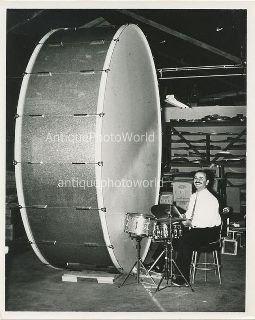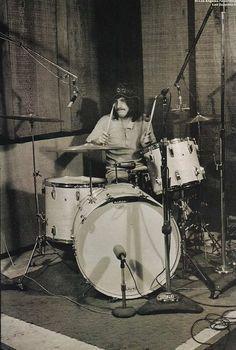The first image is the image on the left, the second image is the image on the right. Examine the images to the left and right. Is the description "One drum contains a silver, oval shaped brand label on the side." accurate? Answer yes or no. No. The first image is the image on the left, the second image is the image on the right. Given the left and right images, does the statement "All drums are lying flat and one drum has an oval label that is facing directly forward." hold true? Answer yes or no. No. 